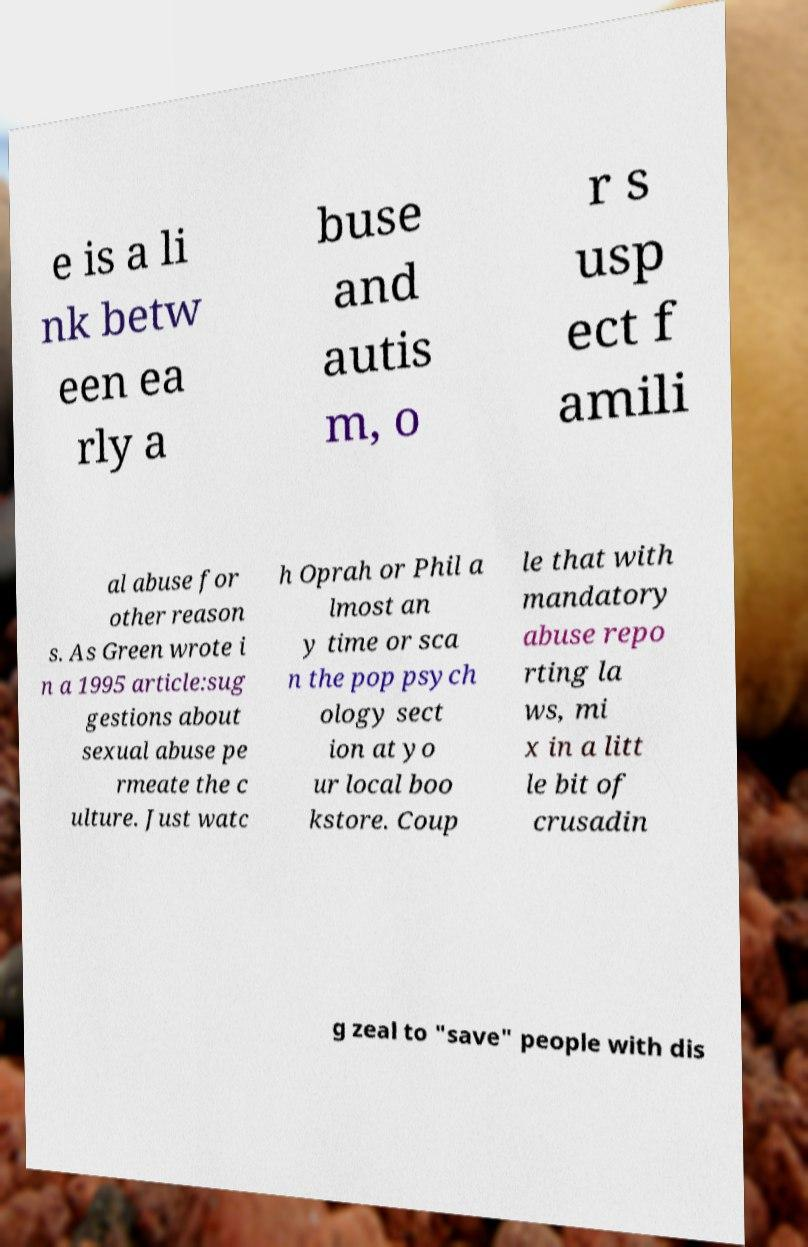Can you accurately transcribe the text from the provided image for me? e is a li nk betw een ea rly a buse and autis m, o r s usp ect f amili al abuse for other reason s. As Green wrote i n a 1995 article:sug gestions about sexual abuse pe rmeate the c ulture. Just watc h Oprah or Phil a lmost an y time or sca n the pop psych ology sect ion at yo ur local boo kstore. Coup le that with mandatory abuse repo rting la ws, mi x in a litt le bit of crusadin g zeal to "save" people with dis 